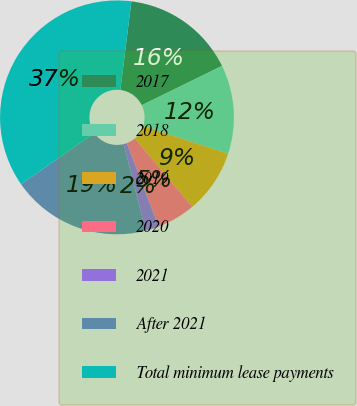Convert chart to OTSL. <chart><loc_0><loc_0><loc_500><loc_500><pie_chart><fcel>2017<fcel>2018<fcel>2019<fcel>2020<fcel>2021<fcel>After 2021<fcel>Total minimum lease payments<nl><fcel>15.78%<fcel>12.3%<fcel>8.82%<fcel>5.34%<fcel>1.86%<fcel>19.25%<fcel>36.65%<nl></chart> 